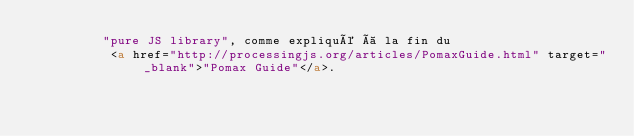<code> <loc_0><loc_0><loc_500><loc_500><_HTML_>         "pure JS library", comme expliqué à la fin du
          <a href="http://processingjs.org/articles/PomaxGuide.html" target="_blank">"Pomax Guide"</a>.</code> 